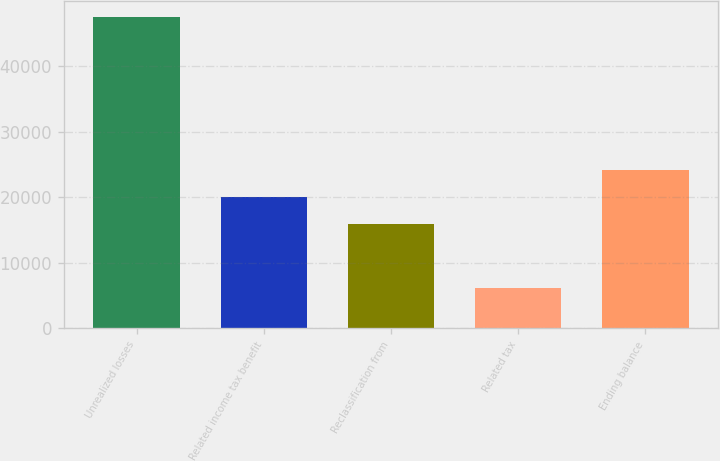Convert chart to OTSL. <chart><loc_0><loc_0><loc_500><loc_500><bar_chart><fcel>Unrealized losses<fcel>Related income tax benefit<fcel>Reclassification from<fcel>Related tax<fcel>Ending balance<nl><fcel>47544<fcel>20046.4<fcel>15911<fcel>6190<fcel>24181.8<nl></chart> 